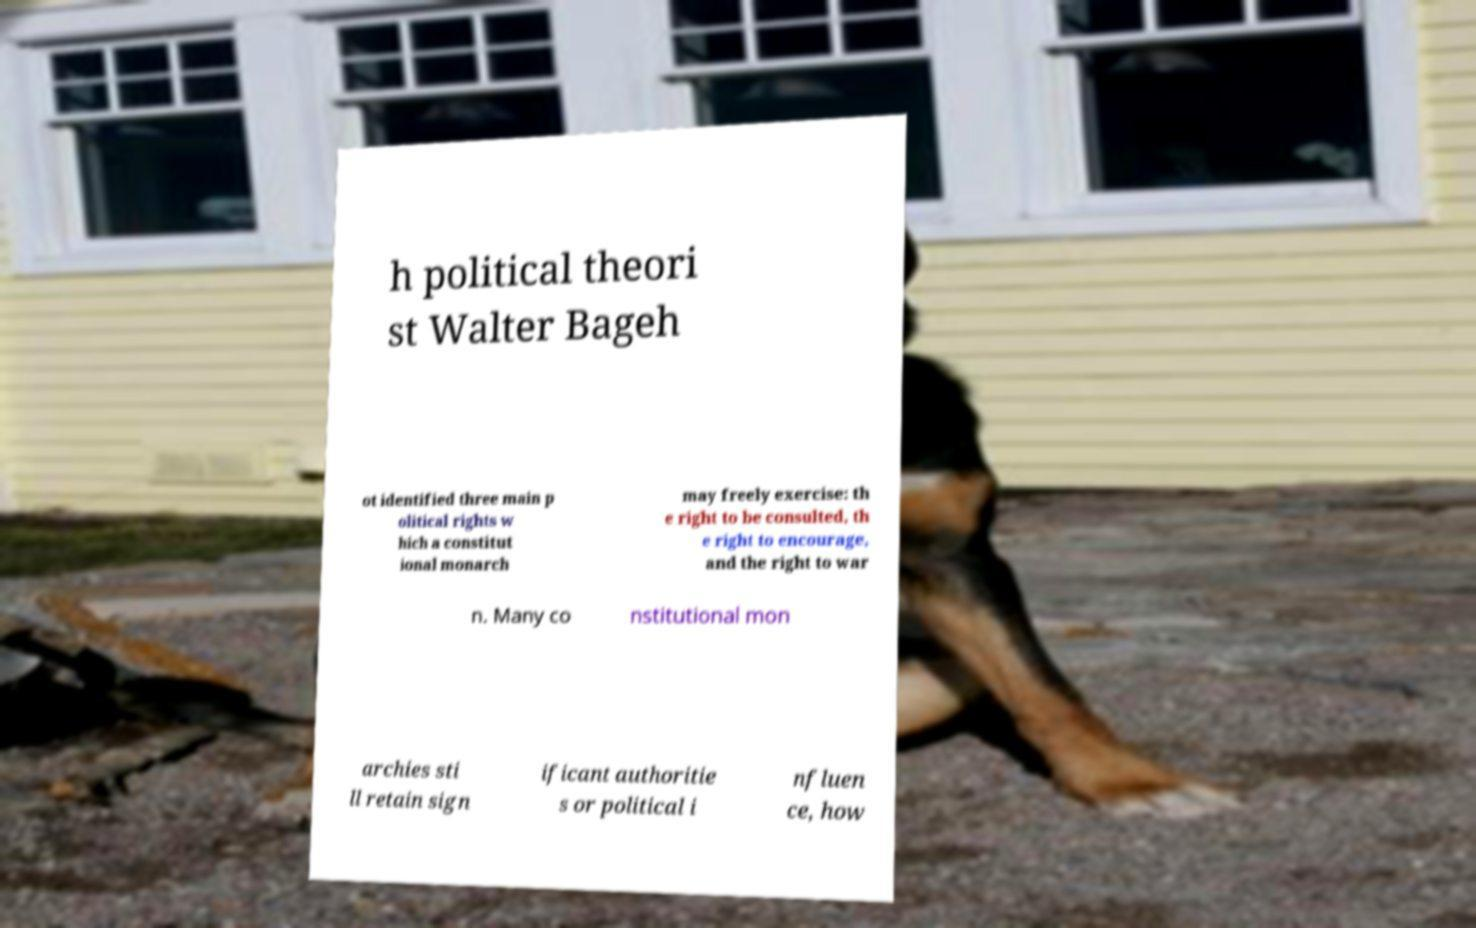Please identify and transcribe the text found in this image. h political theori st Walter Bageh ot identified three main p olitical rights w hich a constitut ional monarch may freely exercise: th e right to be consulted, th e right to encourage, and the right to war n. Many co nstitutional mon archies sti ll retain sign ificant authoritie s or political i nfluen ce, how 